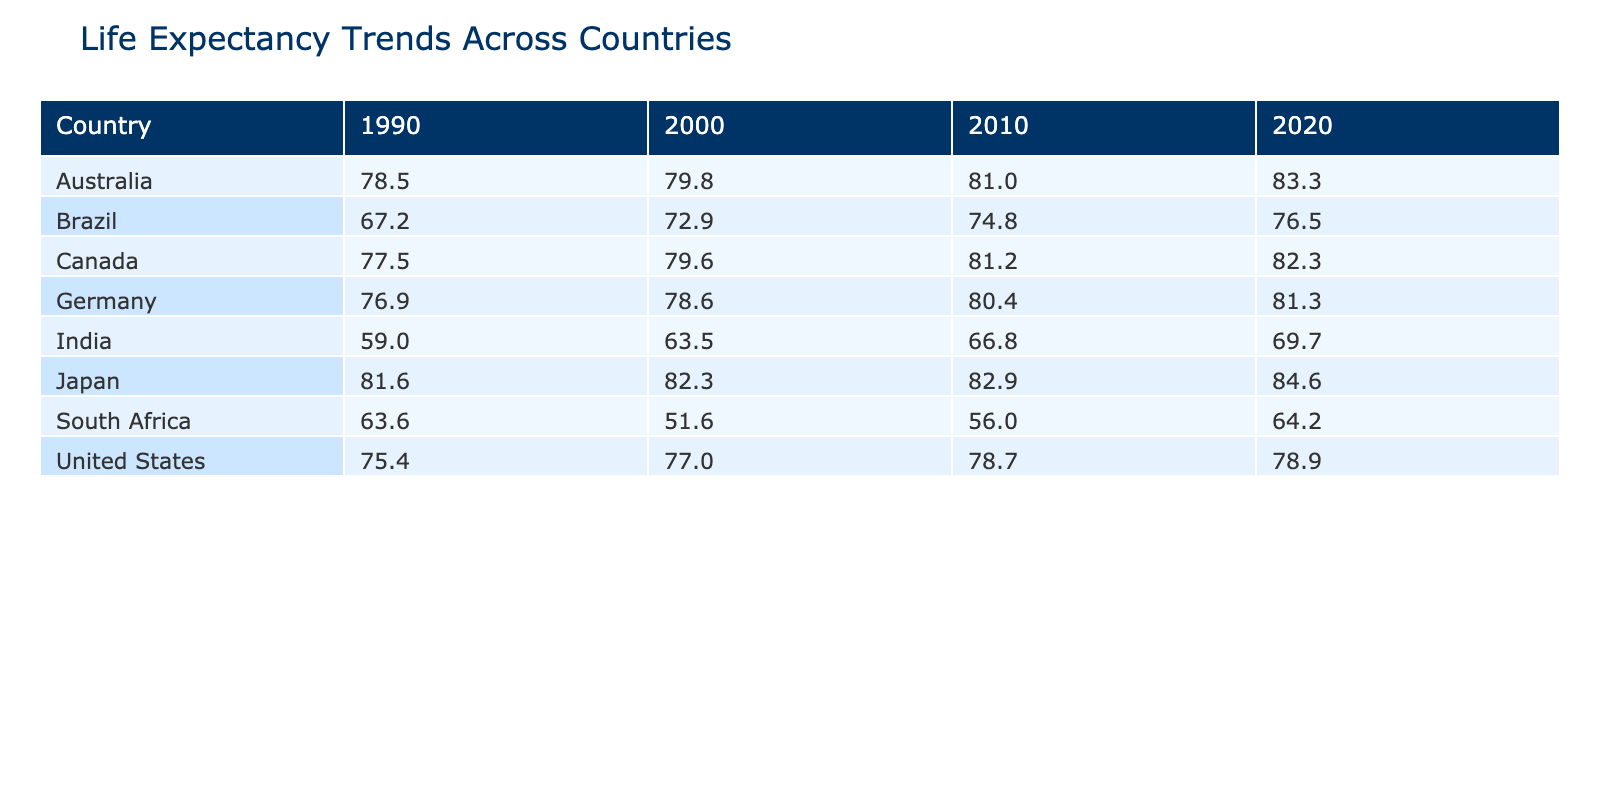What was the life expectancy in Japan in 2020? From the table, the value for Japan in the year 2020 is specifically listed under the Life Expectancy column. It shows that the life expectancy for Japan in that year is 84.6.
Answer: 84.6 Which country had the highest life expectancy in 1990? By reviewing the 1990 row for each country in the table, Japan has the highest life expectancy at 81.6, compared to other countries listed.
Answer: Japan What was the change in life expectancy for the United States from 1990 to 2020? In 1990, the life expectancy for the United States was 75.4. In 2020, it is 78.9. The change can be calculated as 78.9 - 75.4 = 3.5.
Answer: 3.5 Did Canada show an increase in life expectancy every decade from 1990 to 2020? Analyzing the values in the table for Canada, we see the life expectancies for each decade: 1990 (77.5), 2000 (79.6), 2010 (81.2), and 2020 (82.3). Each subsequent year shows an increase.
Answer: Yes What was the average life expectancy for Brazil over the decades? For Brazil, the life expectancy values are: 67.2 (1990), 72.9 (2000), 74.8 (2010), and 76.5 (2020). Summing these gives us 67.2 + 72.9 + 74.8 + 76.5 = 291.4. Dividing by the number of data points, which is 4, the average is 291.4 / 4 = 72.85.
Answer: 72.85 Which country had the lowest life expectancy in 2000? Inspecting the table for the year 2000 shows South Africa with a life expectancy of 51.6, which is the lowest when compared to other countries listed.
Answer: South Africa How much did life expectancy in India improve from 1990 to 2020? Life expectancy in India was 59.0 in 1990 and increased to 69.7 in 2020. The improvement is calculated as 69.7 - 59.0 = 10.7.
Answer: 10.7 Was South Africa's life expectancy higher in 2010 than in 2000? In the table, South Africa's life expectancy in 2000 is 51.6 and in 2010 it is 56.0. Comparing these two values shows that 56.0 is greater than 51.6.
Answer: Yes What country experienced the largest increase in life expectancy from 1990 to 2020? Calculating the change over the years for each country, we find that the increase for Australia is the largest: 83.3 (2020) - 78.5 (1990) = 4.8. Other countries have lesser changes than this.
Answer: Australia 